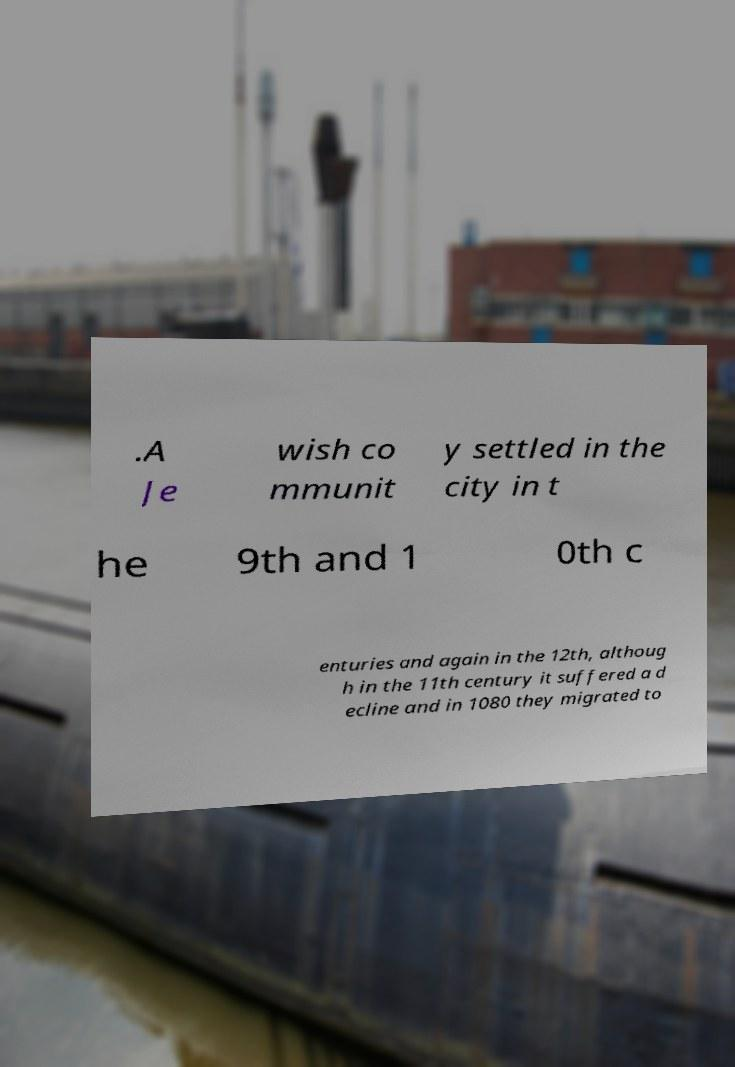Please read and relay the text visible in this image. What does it say? .A Je wish co mmunit y settled in the city in t he 9th and 1 0th c enturies and again in the 12th, althoug h in the 11th century it suffered a d ecline and in 1080 they migrated to 